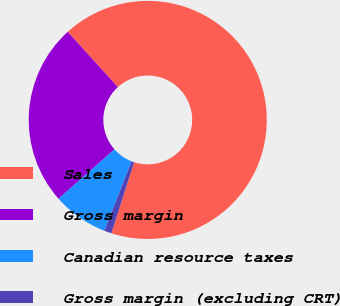<chart> <loc_0><loc_0><loc_500><loc_500><pie_chart><fcel>Sales<fcel>Gross margin<fcel>Canadian resource taxes<fcel>Gross margin (excluding CRT)<nl><fcel>66.69%<fcel>24.78%<fcel>7.55%<fcel>0.98%<nl></chart> 